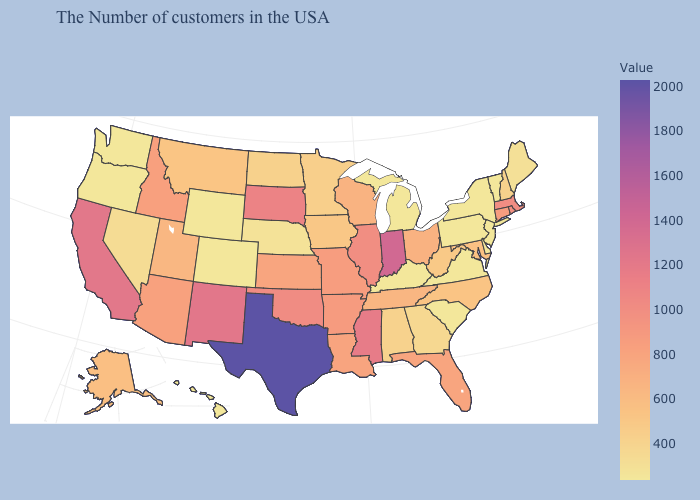Does Texas have the highest value in the USA?
Concise answer only. Yes. Which states hav the highest value in the Northeast?
Be succinct. Massachusetts. Which states have the lowest value in the USA?
Concise answer only. Vermont, New York, New Jersey, Delaware, Pennsylvania, Virginia, South Carolina, Michigan, Kentucky, Wyoming, Colorado, Washington, Oregon, Hawaii. Which states have the lowest value in the USA?
Keep it brief. Vermont, New York, New Jersey, Delaware, Pennsylvania, Virginia, South Carolina, Michigan, Kentucky, Wyoming, Colorado, Washington, Oregon, Hawaii. Among the states that border Florida , which have the highest value?
Answer briefly. Alabama. Which states have the lowest value in the MidWest?
Give a very brief answer. Michigan. Among the states that border Iowa , which have the lowest value?
Give a very brief answer. Nebraska. 